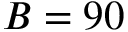<formula> <loc_0><loc_0><loc_500><loc_500>B = 9 0</formula> 